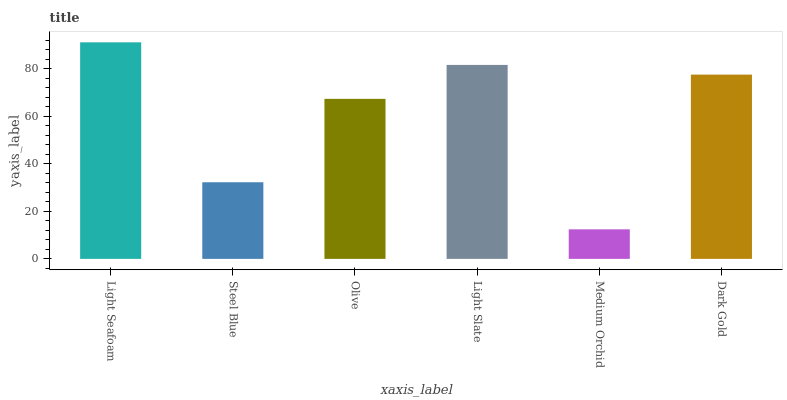Is Medium Orchid the minimum?
Answer yes or no. Yes. Is Light Seafoam the maximum?
Answer yes or no. Yes. Is Steel Blue the minimum?
Answer yes or no. No. Is Steel Blue the maximum?
Answer yes or no. No. Is Light Seafoam greater than Steel Blue?
Answer yes or no. Yes. Is Steel Blue less than Light Seafoam?
Answer yes or no. Yes. Is Steel Blue greater than Light Seafoam?
Answer yes or no. No. Is Light Seafoam less than Steel Blue?
Answer yes or no. No. Is Dark Gold the high median?
Answer yes or no. Yes. Is Olive the low median?
Answer yes or no. Yes. Is Light Seafoam the high median?
Answer yes or no. No. Is Light Seafoam the low median?
Answer yes or no. No. 